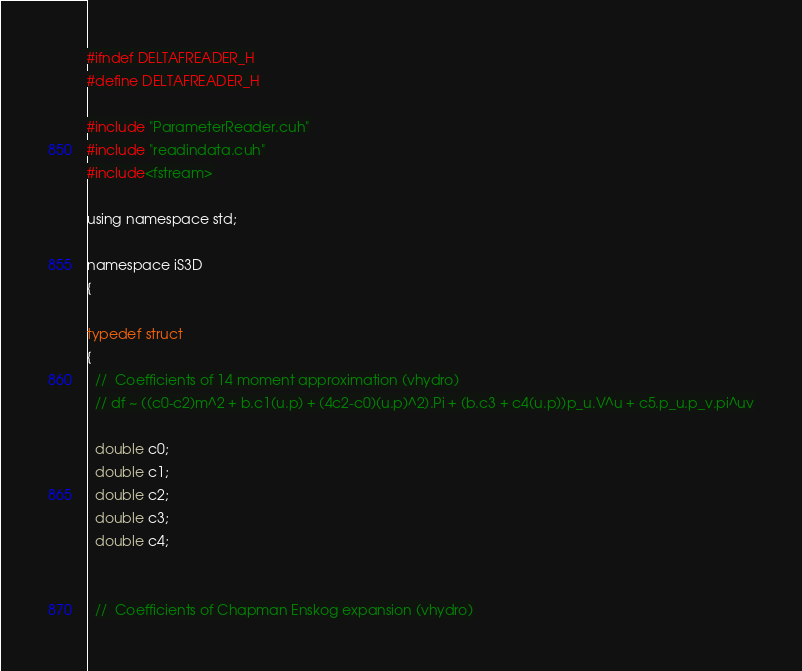Convert code to text. <code><loc_0><loc_0><loc_500><loc_500><_Cuda_>
#ifndef DELTAFREADER_H
#define DELTAFREADER_H

#include "ParameterReader.cuh"
#include "readindata.cuh"
#include<fstream>

using namespace std;

namespace iS3D
{

typedef struct
{
  //  Coefficients of 14 moment approximation (vhydro)
  // df ~ ((c0-c2)m^2 + b.c1(u.p) + (4c2-c0)(u.p)^2).Pi + (b.c3 + c4(u.p))p_u.V^u + c5.p_u.p_v.pi^uv

  double c0;
  double c1;
  double c2;
  double c3;
  double c4;


  //  Coefficients of Chapman Enskog expansion (vhydro)</code> 